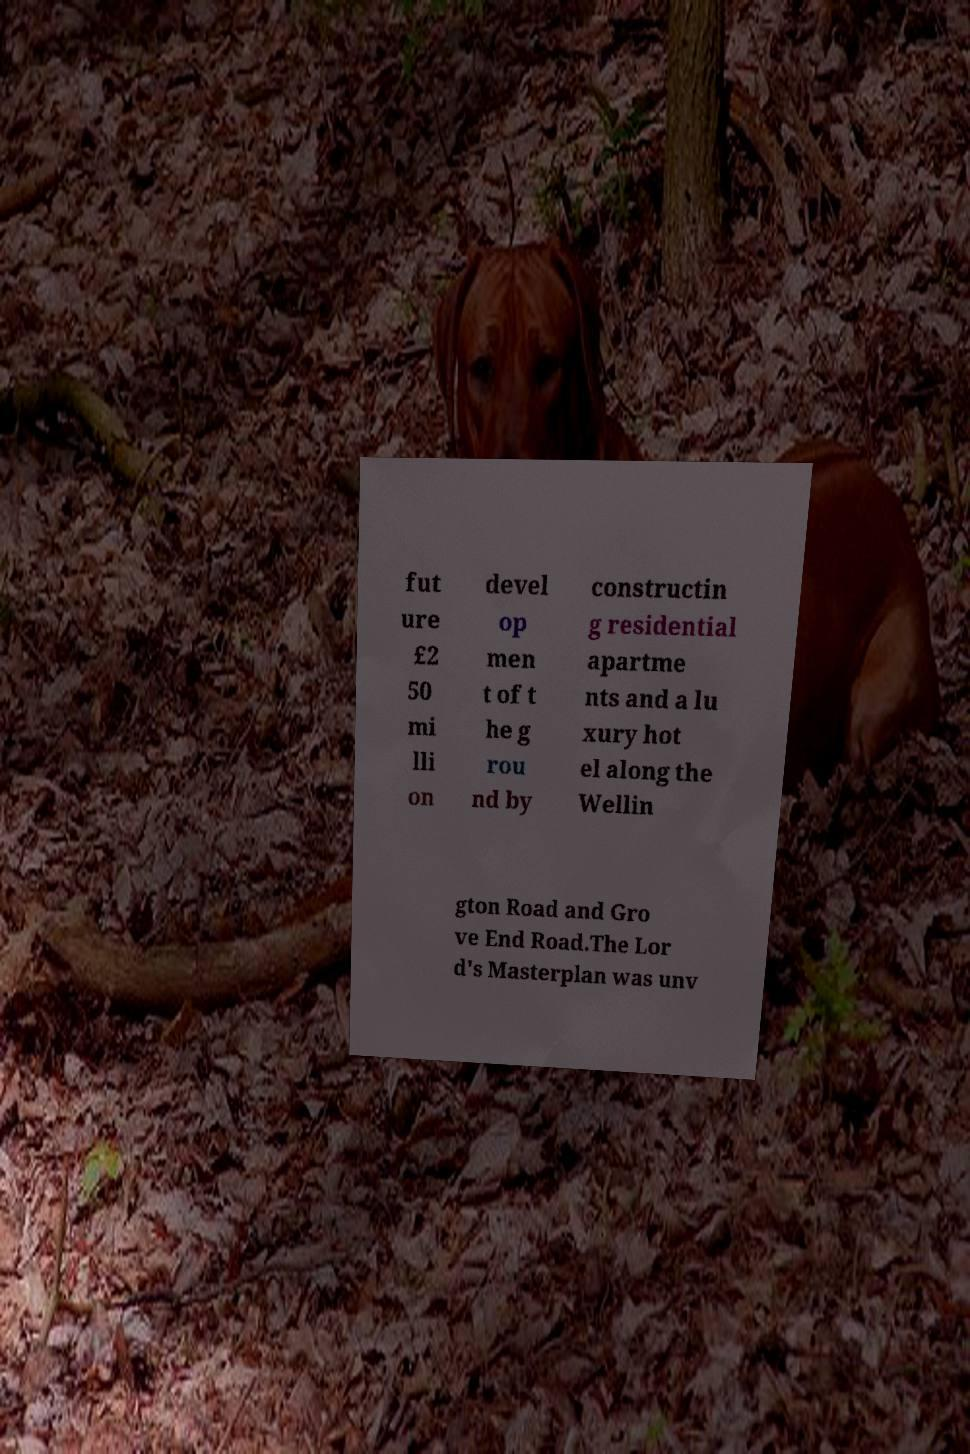Could you assist in decoding the text presented in this image and type it out clearly? fut ure £2 50 mi lli on devel op men t of t he g rou nd by constructin g residential apartme nts and a lu xury hot el along the Wellin gton Road and Gro ve End Road.The Lor d's Masterplan was unv 